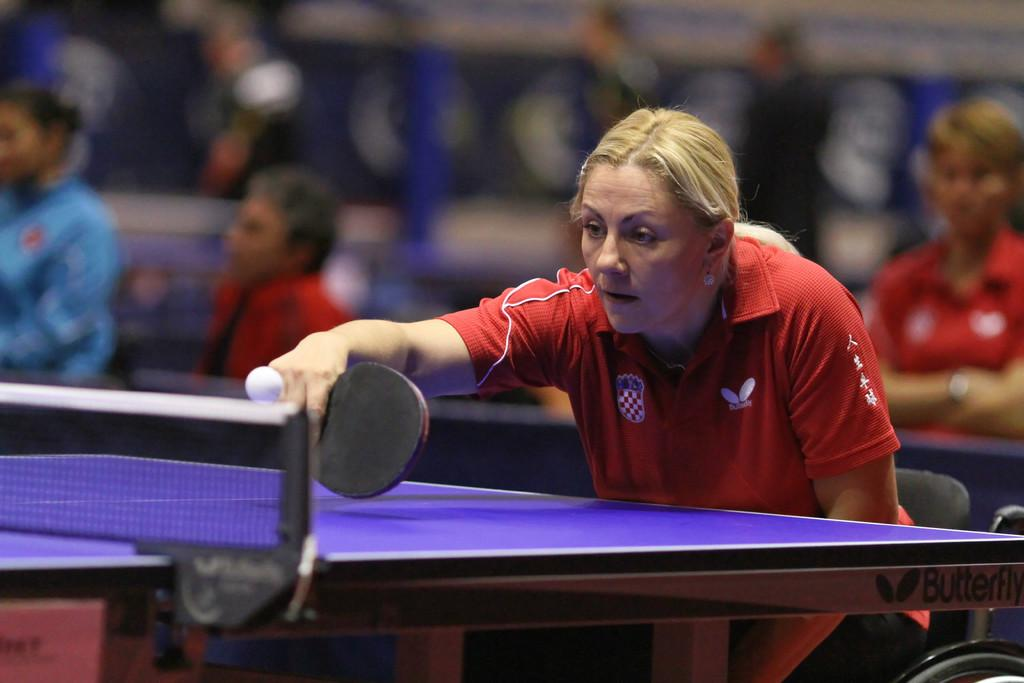What activity is the woman engaged in within the image? The woman is playing table tennis in the image. Can you describe the setting of the image? There are many audience members in the background of the image. Where is the quiver located in the image? There is no quiver present in the image. What type of market can be seen in the background of the image? There is no market visible in the image; it features a woman playing table tennis with audience members in the background. 